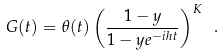Convert formula to latex. <formula><loc_0><loc_0><loc_500><loc_500>G ( t ) = \theta ( t ) \left ( \frac { 1 - y } { 1 - y e ^ { - i h t } } \right ) ^ { K } \ .</formula> 